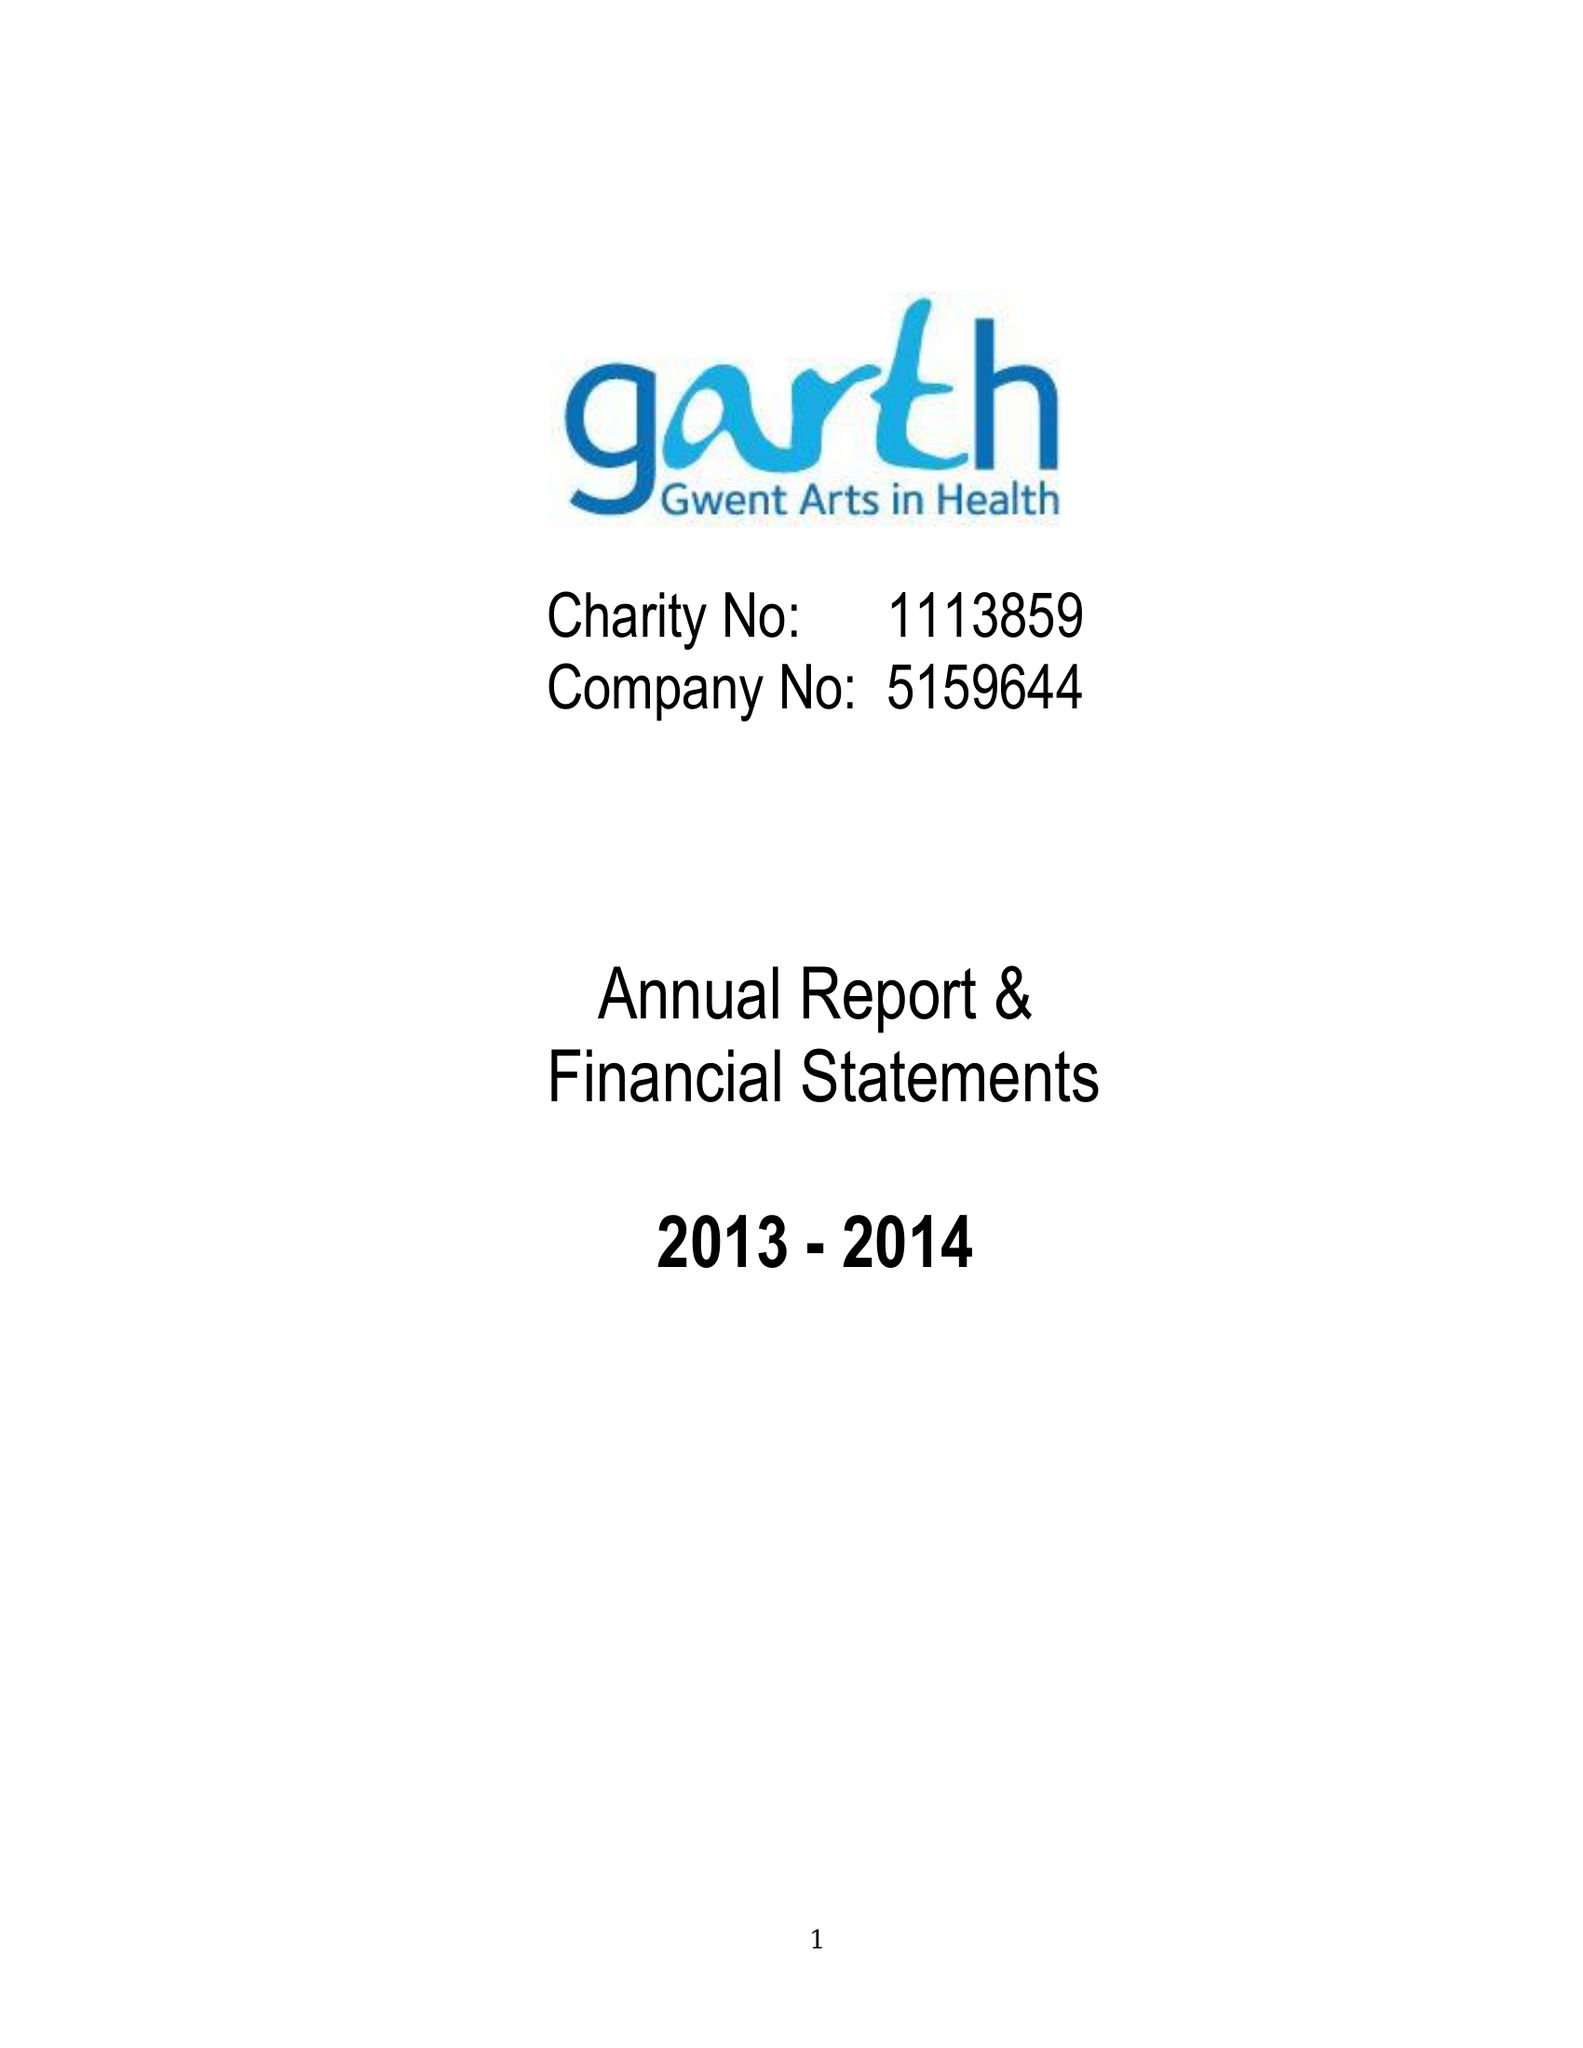What is the value for the address__post_town?
Answer the question using a single word or phrase. NEWPORT 